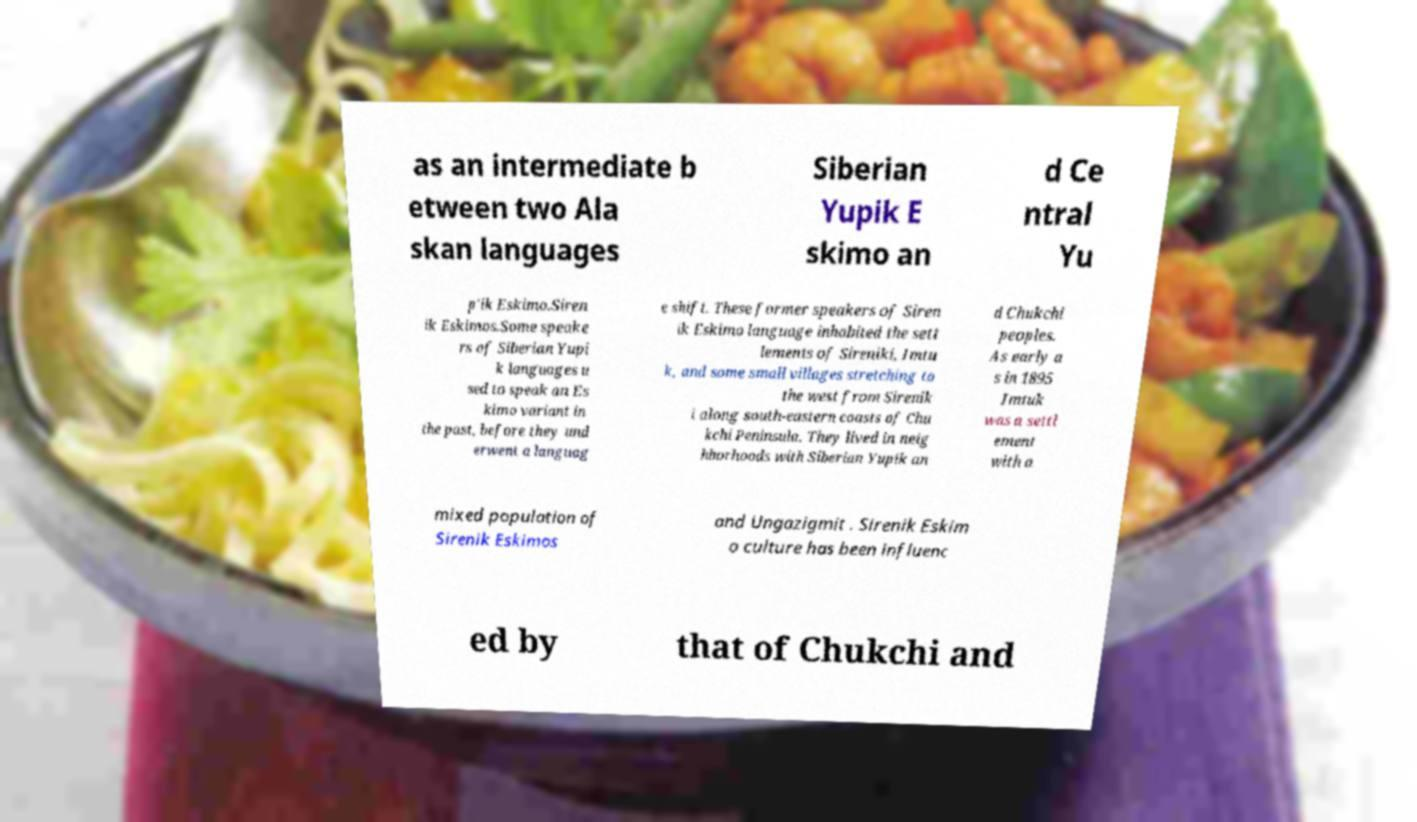There's text embedded in this image that I need extracted. Can you transcribe it verbatim? as an intermediate b etween two Ala skan languages Siberian Yupik E skimo an d Ce ntral Yu p'ik Eskimo.Siren ik Eskimos.Some speake rs of Siberian Yupi k languages u sed to speak an Es kimo variant in the past, before they und erwent a languag e shift. These former speakers of Siren ik Eskimo language inhabited the sett lements of Sireniki, Imtu k, and some small villages stretching to the west from Sirenik i along south-eastern coasts of Chu kchi Peninsula. They lived in neig hborhoods with Siberian Yupik an d Chukchi peoples. As early a s in 1895 Imtuk was a settl ement with a mixed population of Sirenik Eskimos and Ungazigmit . Sirenik Eskim o culture has been influenc ed by that of Chukchi and 